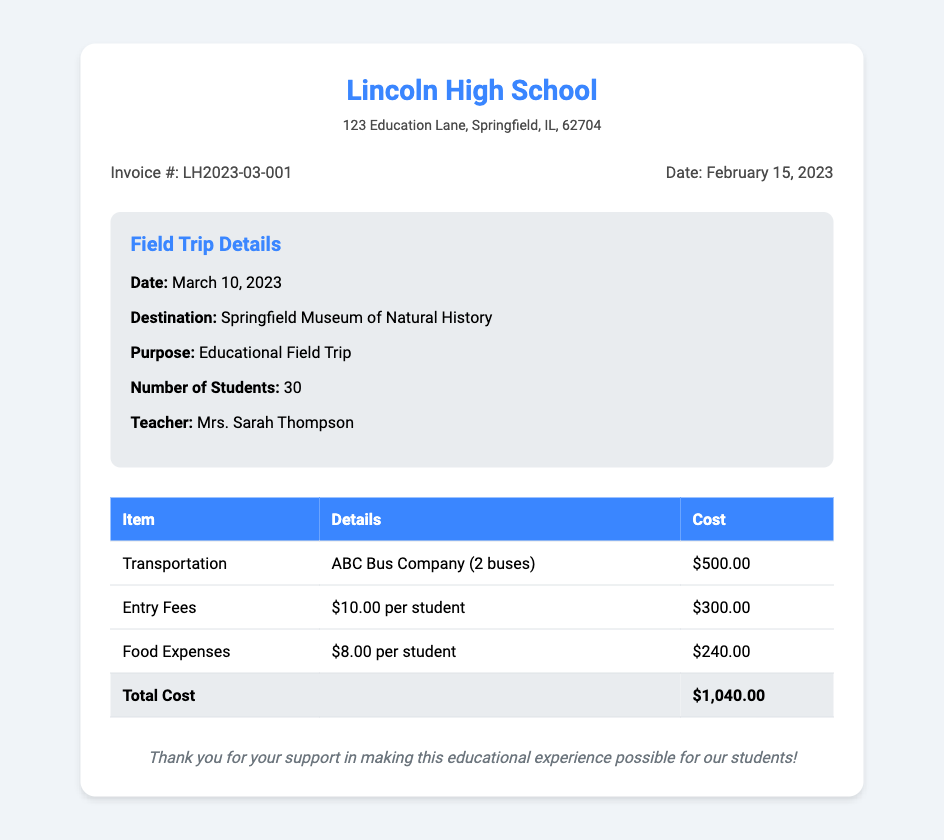What is the school name? The school name is located in the header of the document.
Answer: Lincoln High School What is the invoice number? The invoice number can be found in the invoice details section of the document.
Answer: LH2023-03-001 What is the date of the field trip? The date of the trip is specified in the trip details section of the document.
Answer: March 10, 2023 How many students are attending the trip? The number of students is listed in the trip details section of the document.
Answer: 30 What is the cost for transportation? The cost for transportation is detailed in the cost breakdown table.
Answer: $500.00 What is the total cost of the field trip? The total cost is the sum of all expenses listed in the cost breakdown.
Answer: $1,040.00 Who is the teacher organizing the trip? The teacher's name is mentioned in the trip details section.
Answer: Mrs. Sarah Thompson What is the purpose of the field trip? The purpose of the trip is explicitly stated in the trip details section.
Answer: Educational Field Trip 